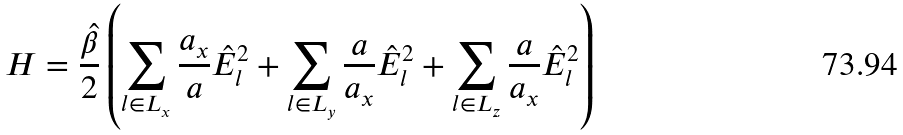<formula> <loc_0><loc_0><loc_500><loc_500>H = \frac { \hat { \beta } } { 2 } \left ( \sum _ { l \in L _ { x } } \frac { a _ { x } } { a } \hat { E } ^ { 2 } _ { l } + \sum _ { l \in L _ { y } } \frac { a } { a _ { x } } \hat { E } ^ { 2 } _ { l } + \sum _ { l \in L _ { z } } \frac { a } { a _ { x } } \hat { E } ^ { 2 } _ { l } \right )</formula> 